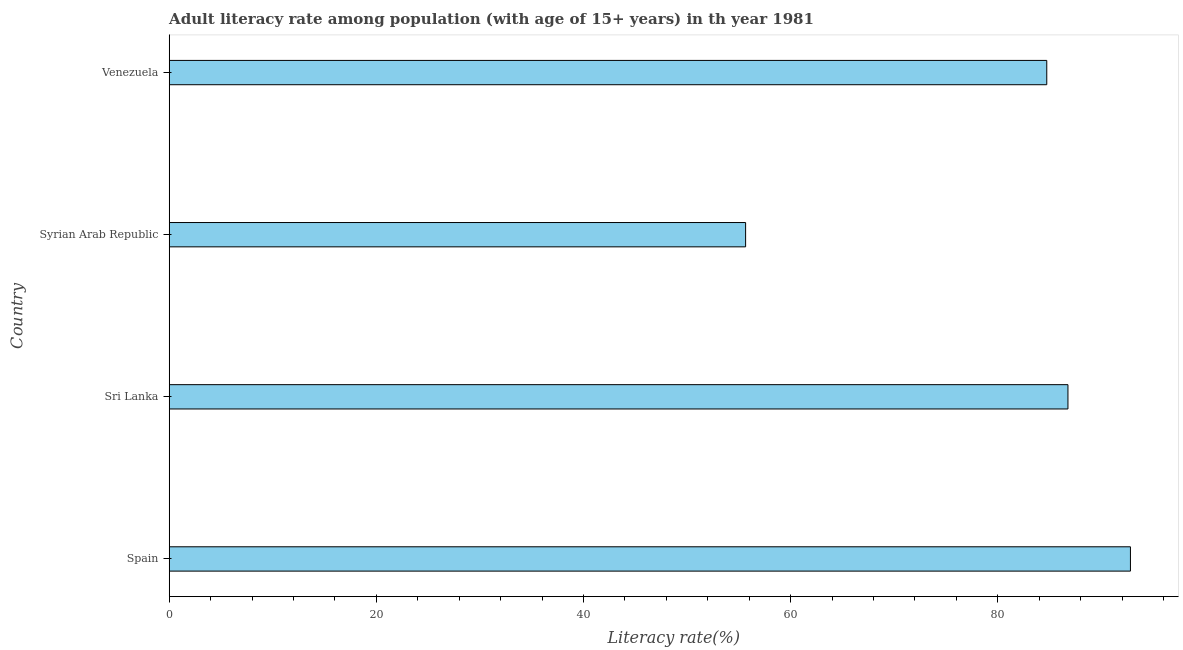Does the graph contain grids?
Provide a short and direct response. No. What is the title of the graph?
Provide a short and direct response. Adult literacy rate among population (with age of 15+ years) in th year 1981. What is the label or title of the X-axis?
Your answer should be very brief. Literacy rate(%). What is the adult literacy rate in Spain?
Your answer should be compact. 92.81. Across all countries, what is the maximum adult literacy rate?
Give a very brief answer. 92.81. Across all countries, what is the minimum adult literacy rate?
Ensure brevity in your answer.  55.65. In which country was the adult literacy rate maximum?
Your answer should be very brief. Spain. In which country was the adult literacy rate minimum?
Offer a terse response. Syrian Arab Republic. What is the sum of the adult literacy rate?
Your answer should be compact. 319.97. What is the difference between the adult literacy rate in Sri Lanka and Syrian Arab Republic?
Ensure brevity in your answer.  31.12. What is the average adult literacy rate per country?
Provide a succinct answer. 79.99. What is the median adult literacy rate?
Provide a short and direct response. 85.76. What is the ratio of the adult literacy rate in Sri Lanka to that in Syrian Arab Republic?
Make the answer very short. 1.56. Is the difference between the adult literacy rate in Spain and Venezuela greater than the difference between any two countries?
Offer a terse response. No. What is the difference between the highest and the second highest adult literacy rate?
Keep it short and to the point. 6.03. What is the difference between the highest and the lowest adult literacy rate?
Ensure brevity in your answer.  37.16. Are all the bars in the graph horizontal?
Give a very brief answer. Yes. How many countries are there in the graph?
Offer a terse response. 4. What is the Literacy rate(%) in Spain?
Give a very brief answer. 92.81. What is the Literacy rate(%) in Sri Lanka?
Your answer should be very brief. 86.78. What is the Literacy rate(%) in Syrian Arab Republic?
Make the answer very short. 55.65. What is the Literacy rate(%) of Venezuela?
Ensure brevity in your answer.  84.73. What is the difference between the Literacy rate(%) in Spain and Sri Lanka?
Provide a short and direct response. 6.03. What is the difference between the Literacy rate(%) in Spain and Syrian Arab Republic?
Offer a very short reply. 37.16. What is the difference between the Literacy rate(%) in Spain and Venezuela?
Offer a very short reply. 8.08. What is the difference between the Literacy rate(%) in Sri Lanka and Syrian Arab Republic?
Your answer should be very brief. 31.12. What is the difference between the Literacy rate(%) in Sri Lanka and Venezuela?
Give a very brief answer. 2.05. What is the difference between the Literacy rate(%) in Syrian Arab Republic and Venezuela?
Offer a very short reply. -29.08. What is the ratio of the Literacy rate(%) in Spain to that in Sri Lanka?
Make the answer very short. 1.07. What is the ratio of the Literacy rate(%) in Spain to that in Syrian Arab Republic?
Your answer should be very brief. 1.67. What is the ratio of the Literacy rate(%) in Spain to that in Venezuela?
Your answer should be very brief. 1.09. What is the ratio of the Literacy rate(%) in Sri Lanka to that in Syrian Arab Republic?
Give a very brief answer. 1.56. What is the ratio of the Literacy rate(%) in Syrian Arab Republic to that in Venezuela?
Give a very brief answer. 0.66. 